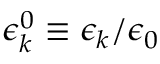Convert formula to latex. <formula><loc_0><loc_0><loc_500><loc_500>\epsilon _ { k } ^ { 0 } \equiv \epsilon _ { k } / { \epsilon _ { 0 } }</formula> 